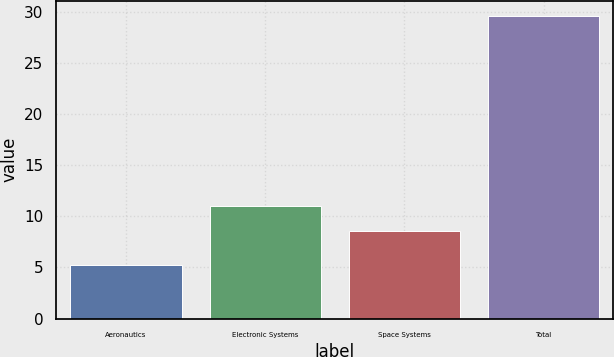<chart> <loc_0><loc_0><loc_500><loc_500><bar_chart><fcel>Aeronautics<fcel>Electronic Systems<fcel>Space Systems<fcel>Total<nl><fcel>5.2<fcel>11.04<fcel>8.6<fcel>29.6<nl></chart> 